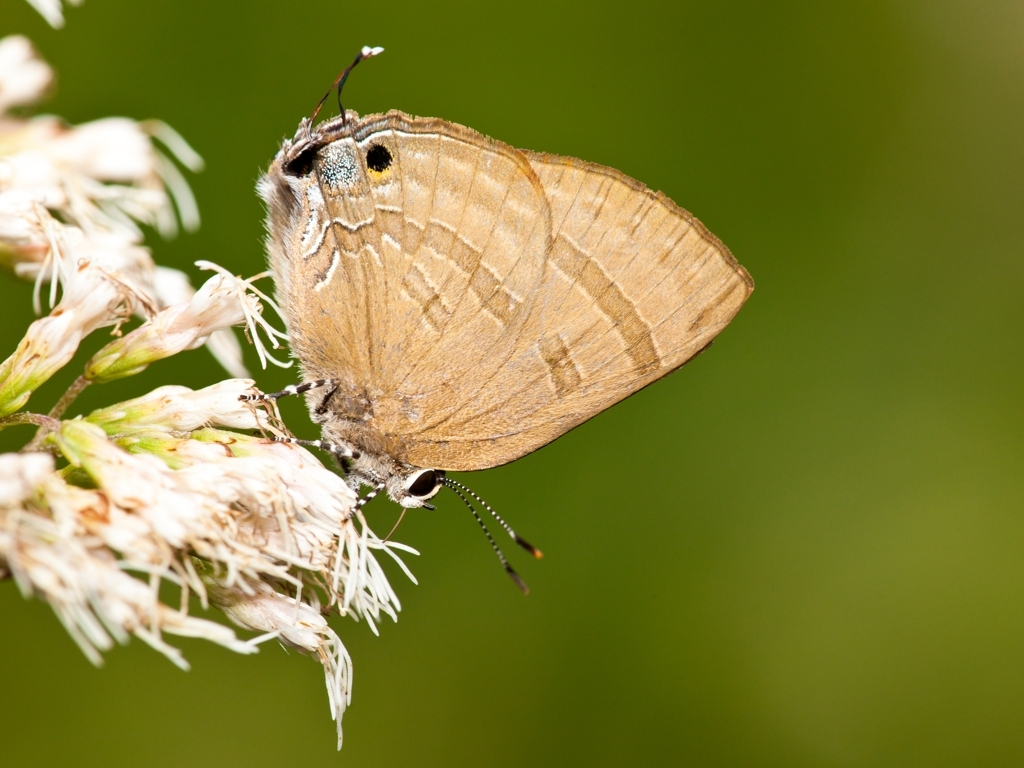Can you tell me which species of butterfly is in this picture? While I can't specifically identify species, the butterfly in the image appears to be of the Lycaenidae family, known for their small size and intricate patterns. To get an exact species identification, one might need to consult a lepidopterist or a detailed field guide. 